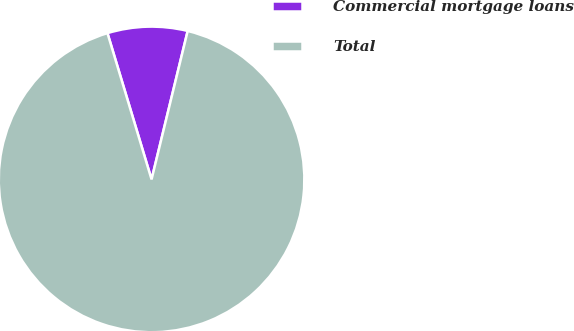<chart> <loc_0><loc_0><loc_500><loc_500><pie_chart><fcel>Commercial mortgage loans<fcel>Total<nl><fcel>8.46%<fcel>91.54%<nl></chart> 